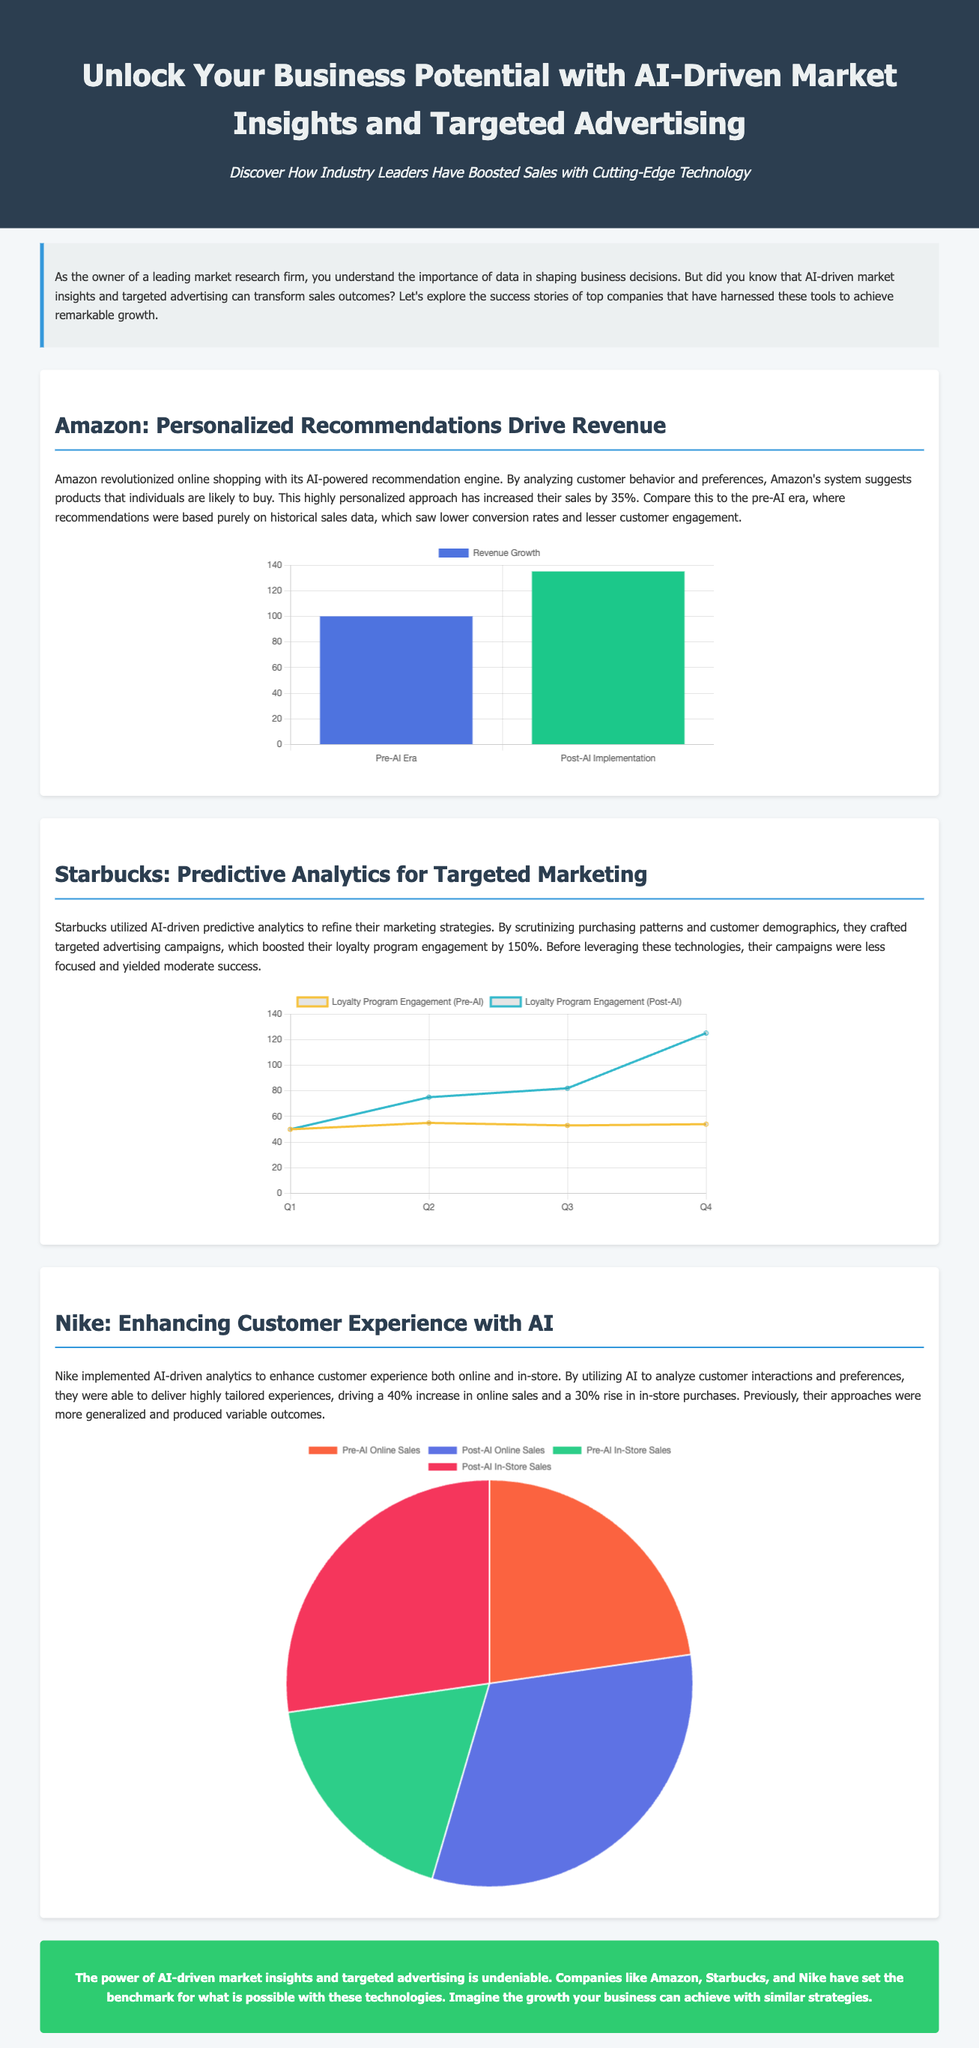What company boosted sales by 35%? The document mentions that Amazon increased sales by 35% through AI-powered recommendations.
Answer: Amazon What was the engagement increase percentage for Starbucks' loyalty program? Starbucks crafted targeted campaigns that boosted their loyalty program engagement by 150%.
Answer: 150% What type of chart is used for Amazon's revenue growth? The visual information for Amazon's revenue growth is represented with a bar chart.
Answer: Bar What were Nike's online sales growth percentages before and after AI implementation? Before AI, online sales accounted for 25%, and after AI implementation, they accounted for 35%.
Answer: 25% and 35% What analytics did Starbucks use for their marketing strategies? Starbucks utilized AI-driven predictive analytics to refine their marketing strategies.
Answer: Predictive analytics Which company experienced a 40% increase in online sales? The document states that Nike saw a 40% increase in online sales through AI-driven analytics.
Answer: Nike What was the pre-AI engagement number for Starbucks’ loyalty program in Q4? The pre-AI engagement for Starbucks’ loyalty program in Q4 was recorded as 54.
Answer: 54 What is the main theme of the advertisement? The overall theme of the advertisement emphasizes the benefits of AI-driven market insights and targeted advertising.
Answer: AI-driven market insights What color represents post-AI implementation in Starbucks' chart? The post-AI implementation data for Starbucks' chart is represented with a color that corresponds to the label '#36b9cc'.
Answer: #36b9cc 